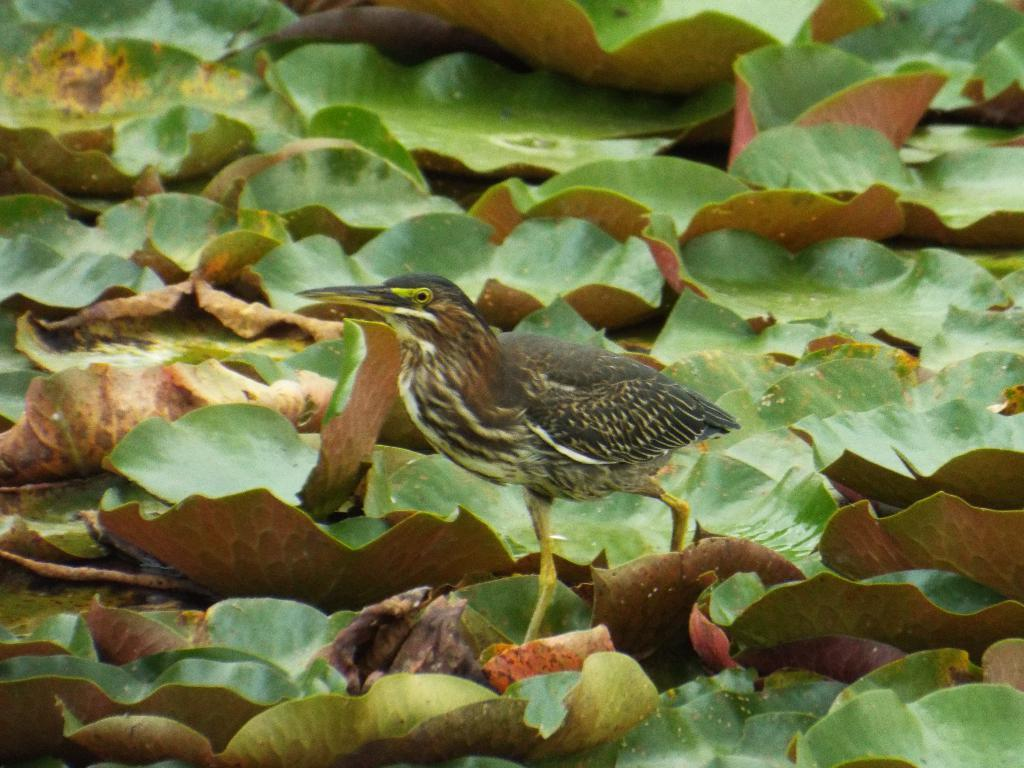What type of animal can be seen in the image? There is a bird in the image. What colors are present on the bird? The bird has black, white, and brown colors. Where is the bird located in the image? The bird is on leaves. What colors are present on the leaves? The leaves are green and brown in color. What type of servant can be seen attending to the bird in the image? There is no servant present in the image; it only features a bird on leaves. 